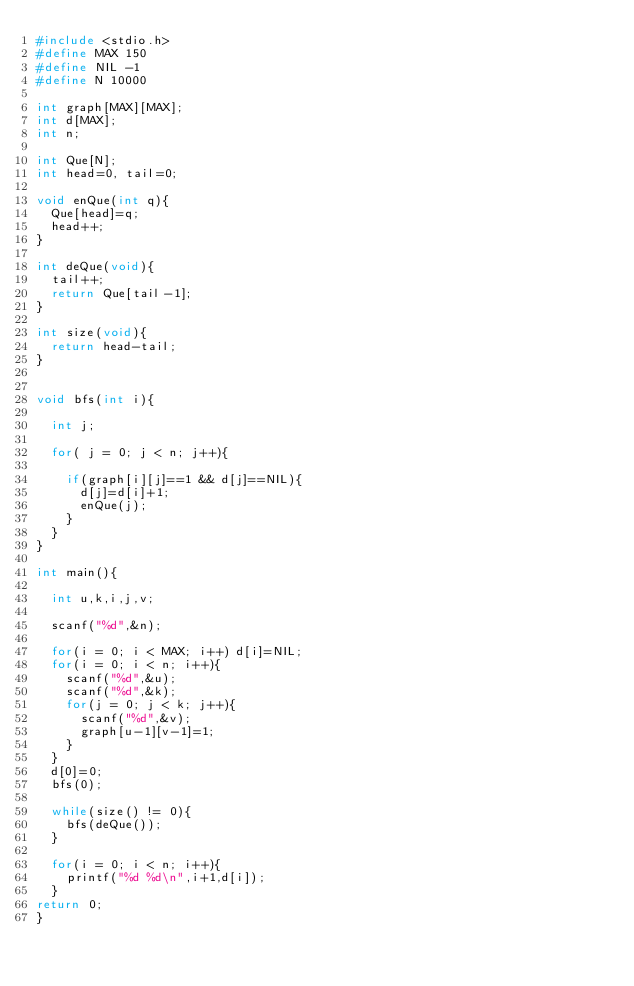Convert code to text. <code><loc_0><loc_0><loc_500><loc_500><_C_>#include <stdio.h>
#define MAX 150
#define NIL -1
#define N 10000

int graph[MAX][MAX];
int d[MAX];
int n;
  
int Que[N];
int head=0, tail=0;
 
void enQue(int q){
  Que[head]=q;
  head++;
}
 
int deQue(void){
  tail++;
  return Que[tail-1];
}
 
int size(void){
  return head-tail;
}
 
 
void bfs(int i){

  int j;
  
  for( j = 0; j < n; j++){
  
    if(graph[i][j]==1 && d[j]==NIL){
      d[j]=d[i]+1;
      enQue(j);
    }
  }
}
 
int main(){

  int u,k,i,j,v;
  
  scanf("%d",&n);
  
  for(i = 0; i < MAX; i++) d[i]=NIL;
  for(i = 0; i < n; i++){
    scanf("%d",&u);
    scanf("%d",&k);
    for(j = 0; j < k; j++){
      scanf("%d",&v);
      graph[u-1][v-1]=1;
    } 
  }
  d[0]=0;
  bfs(0);
  
  while(size() != 0){
    bfs(deQue());
  }
  
  for(i = 0; i < n; i++){
    printf("%d %d\n",i+1,d[i]);
  }
return 0;
}
</code> 